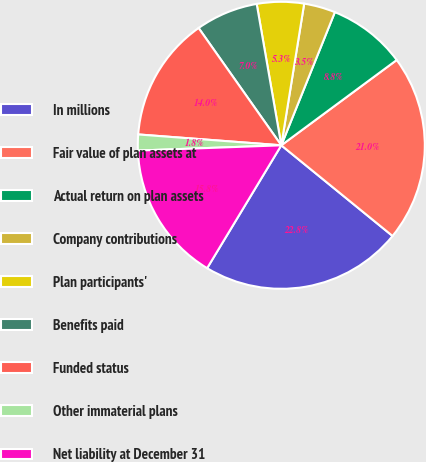Convert chart. <chart><loc_0><loc_0><loc_500><loc_500><pie_chart><fcel>In millions<fcel>Fair value of plan assets at<fcel>Actual return on plan assets<fcel>Company contributions<fcel>Plan participants'<fcel>Benefits paid<fcel>Funded status<fcel>Other immaterial plans<fcel>Net liability at December 31<nl><fcel>22.76%<fcel>21.01%<fcel>8.78%<fcel>3.54%<fcel>5.29%<fcel>7.03%<fcel>14.02%<fcel>1.79%<fcel>15.77%<nl></chart> 